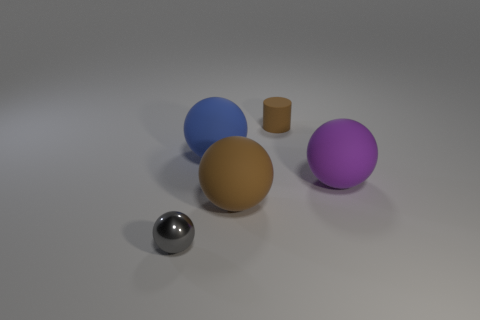What size is the matte ball that is both right of the big blue sphere and on the left side of the purple thing?
Offer a terse response. Large. There is a shiny sphere; does it have the same color as the rubber ball to the right of the small cylinder?
Your answer should be very brief. No. Is there a large green metal object of the same shape as the large purple thing?
Provide a short and direct response. No. What number of objects are blue shiny spheres or rubber balls that are behind the purple rubber thing?
Your answer should be compact. 1. How many other objects are there of the same material as the tiny ball?
Your response must be concise. 0. What number of objects are either tiny gray shiny balls or big things?
Offer a very short reply. 4. Is the number of big purple balls that are in front of the shiny ball greater than the number of balls in front of the purple rubber object?
Provide a succinct answer. No. There is a tiny object that is behind the shiny thing; does it have the same color as the matte ball behind the large purple sphere?
Ensure brevity in your answer.  No. How big is the brown matte thing that is in front of the small object that is behind the large object behind the purple matte ball?
Ensure brevity in your answer.  Large. There is another shiny thing that is the same shape as the big blue object; what is its color?
Your response must be concise. Gray. 